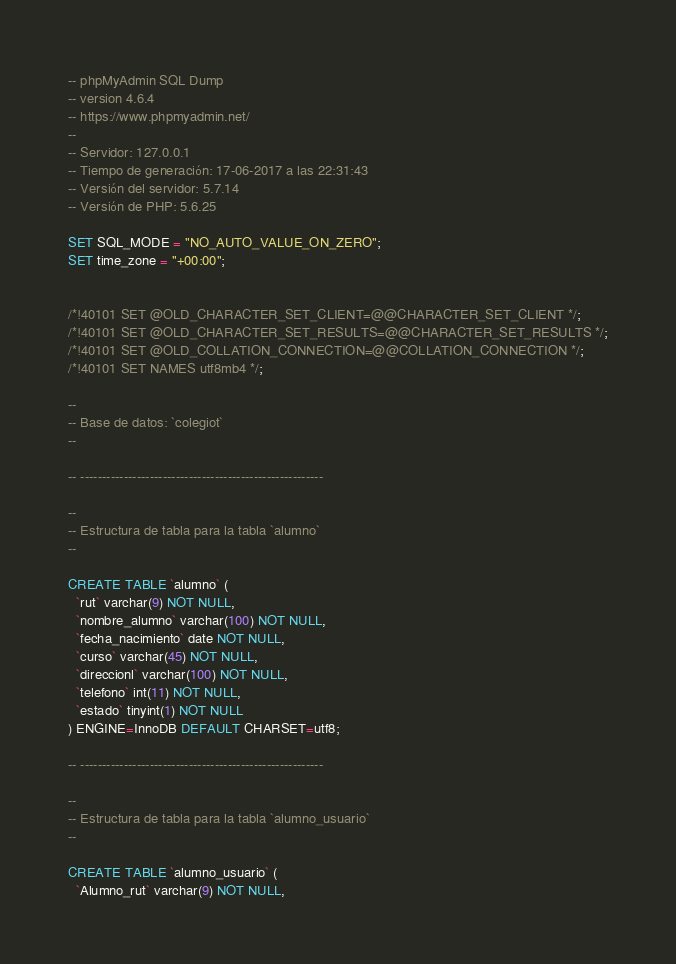<code> <loc_0><loc_0><loc_500><loc_500><_SQL_>-- phpMyAdmin SQL Dump
-- version 4.6.4
-- https://www.phpmyadmin.net/
--
-- Servidor: 127.0.0.1
-- Tiempo de generación: 17-06-2017 a las 22:31:43
-- Versión del servidor: 5.7.14
-- Versión de PHP: 5.6.25

SET SQL_MODE = "NO_AUTO_VALUE_ON_ZERO";
SET time_zone = "+00:00";


/*!40101 SET @OLD_CHARACTER_SET_CLIENT=@@CHARACTER_SET_CLIENT */;
/*!40101 SET @OLD_CHARACTER_SET_RESULTS=@@CHARACTER_SET_RESULTS */;
/*!40101 SET @OLD_COLLATION_CONNECTION=@@COLLATION_CONNECTION */;
/*!40101 SET NAMES utf8mb4 */;

--
-- Base de datos: `colegiot`
--

-- --------------------------------------------------------

--
-- Estructura de tabla para la tabla `alumno`
--

CREATE TABLE `alumno` (
  `rut` varchar(9) NOT NULL,
  `nombre_alumno` varchar(100) NOT NULL,
  `fecha_nacimiento` date NOT NULL,
  `curso` varchar(45) NOT NULL,
  `direccionl` varchar(100) NOT NULL,
  `telefono` int(11) NOT NULL,
  `estado` tinyint(1) NOT NULL
) ENGINE=InnoDB DEFAULT CHARSET=utf8;

-- --------------------------------------------------------

--
-- Estructura de tabla para la tabla `alumno_usuario`
--

CREATE TABLE `alumno_usuario` (
  `Alumno_rut` varchar(9) NOT NULL,</code> 